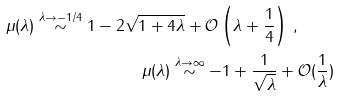<formula> <loc_0><loc_0><loc_500><loc_500>\mu ( \lambda ) \stackrel { \lambda \to - 1 / 4 } { \sim } 1 - 2 \sqrt { 1 + 4 \lambda } + { \mathcal { O } } \left ( \lambda + \frac { 1 } { 4 } \right ) \, , \quad \\ \mu ( \lambda ) \stackrel { \lambda \to \infty } { \sim } - 1 + \frac { 1 } { \sqrt { \lambda } } + { \mathcal { O } } ( \frac { 1 } { \lambda } )</formula> 